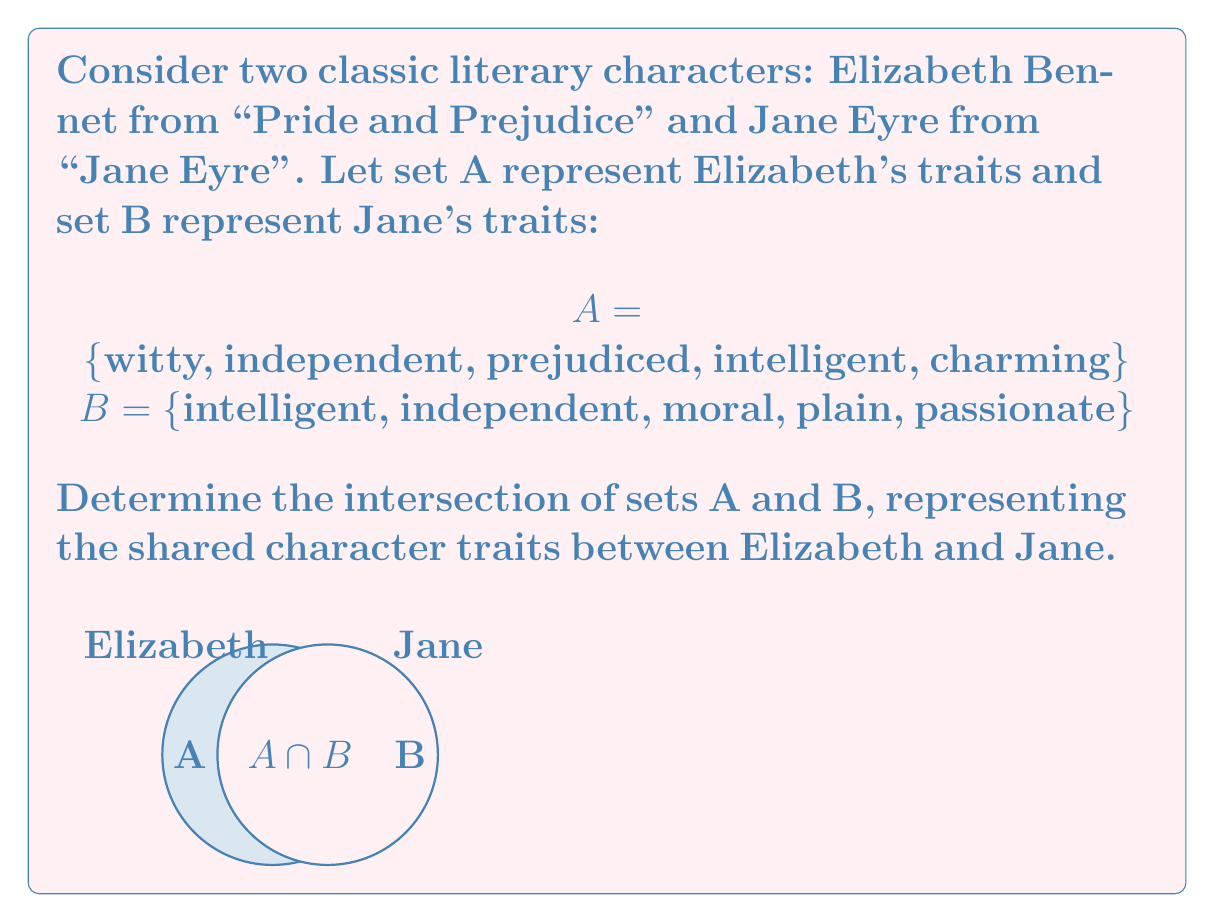What is the answer to this math problem? To find the intersection of sets A and B, we need to identify the elements that are common to both sets. Let's go through this step-by-step:

1) First, let's list out the elements of each set:
   A = {witty, independent, prejudiced, intelligent, charming}
   B = {intelligent, independent, moral, plain, passionate}

2) Now, we need to identify which elements appear in both sets:

   - "witty" is in A but not in B
   - "independent" is in both A and B
   - "prejudiced" is in A but not in B
   - "intelligent" is in both A and B
   - "charming" is in A but not in B
   - "moral" is in B but not in A
   - "plain" is in B but not in A
   - "passionate" is in B but not in A

3) The elements that appear in both sets are "independent" and "intelligent".

4) Therefore, the intersection of A and B, denoted as $A \cap B$, is:

   $A \cap B = \text{\{independent, intelligent\}}$

This intersection represents the character traits that Elizabeth Bennet and Jane Eyre share in common.
Answer: $A \cap B = \text{\{independent, intelligent\}}$ 